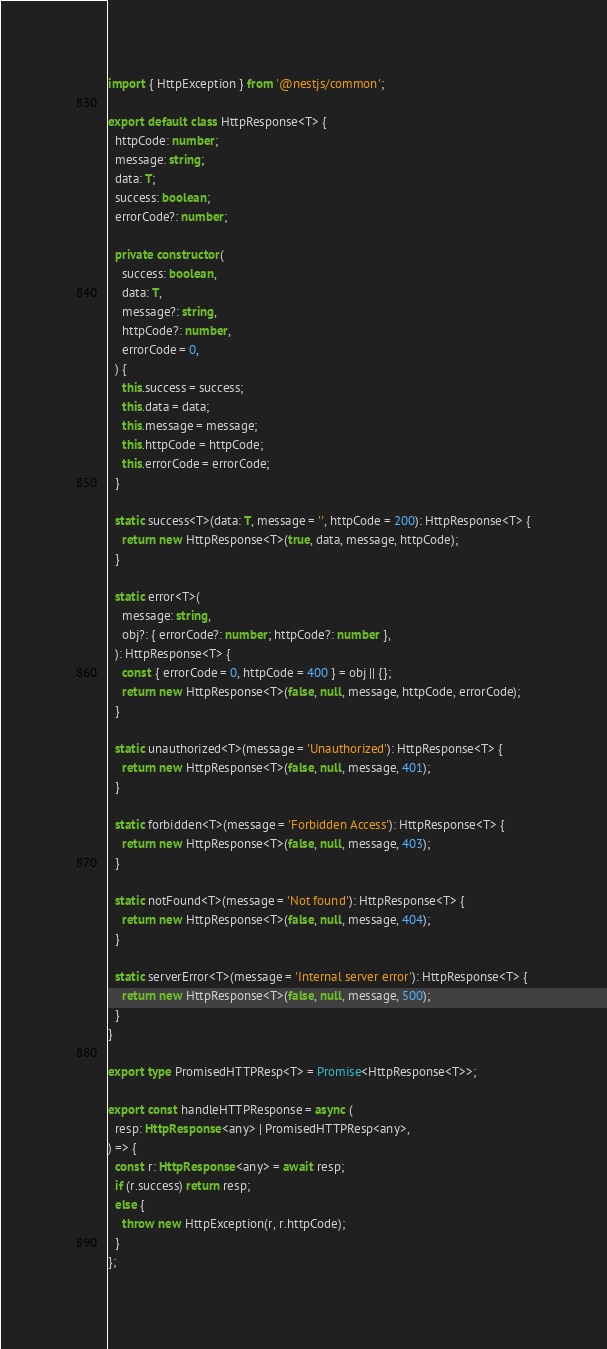<code> <loc_0><loc_0><loc_500><loc_500><_TypeScript_>import { HttpException } from '@nestjs/common';

export default class HttpResponse<T> {
  httpCode: number;
  message: string;
  data: T;
  success: boolean;
  errorCode?: number;

  private constructor(
    success: boolean,
    data: T,
    message?: string,
    httpCode?: number,
    errorCode = 0,
  ) {
    this.success = success;
    this.data = data;
    this.message = message;
    this.httpCode = httpCode;
    this.errorCode = errorCode;
  }

  static success<T>(data: T, message = '', httpCode = 200): HttpResponse<T> {
    return new HttpResponse<T>(true, data, message, httpCode);
  }

  static error<T>(
    message: string,
    obj?: { errorCode?: number; httpCode?: number },
  ): HttpResponse<T> {
    const { errorCode = 0, httpCode = 400 } = obj || {};
    return new HttpResponse<T>(false, null, message, httpCode, errorCode);
  }

  static unauthorized<T>(message = 'Unauthorized'): HttpResponse<T> {
    return new HttpResponse<T>(false, null, message, 401);
  }

  static forbidden<T>(message = 'Forbidden Access'): HttpResponse<T> {
    return new HttpResponse<T>(false, null, message, 403);
  }

  static notFound<T>(message = 'Not found'): HttpResponse<T> {
    return new HttpResponse<T>(false, null, message, 404);
  }

  static serverError<T>(message = 'Internal server error'): HttpResponse<T> {
    return new HttpResponse<T>(false, null, message, 500);
  }
}

export type PromisedHTTPResp<T> = Promise<HttpResponse<T>>;

export const handleHTTPResponse = async (
  resp: HttpResponse<any> | PromisedHTTPResp<any>,
) => {
  const r: HttpResponse<any> = await resp;
  if (r.success) return resp;
  else {
    throw new HttpException(r, r.httpCode);
  }
};
</code> 